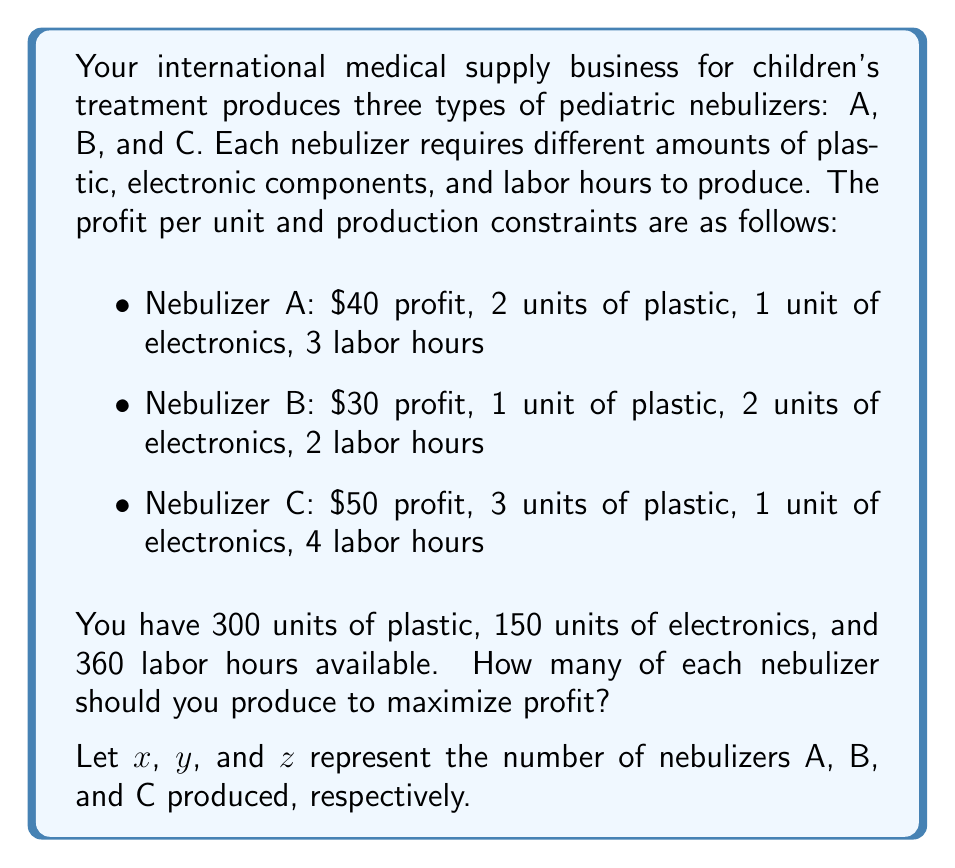Help me with this question. To solve this problem, we'll use a system of linear equations and the simplex method for linear programming. Here's the step-by-step solution:

1. Set up the objective function to maximize profit:
   $$P = 40x + 30y + 50z$$

2. Define the constraints:
   Plastic: $2x + y + 3z \leq 300$
   Electronics: $x + 2y + z \leq 150$
   Labor: $3x + 2y + 4z \leq 360$

3. Add non-negativity constraints:
   $x \geq 0$, $y \geq 0$, $z \geq 0$

4. Convert to standard form by adding slack variables:
   $$2x + y + 3z + s_1 = 300$$
   $$x + 2y + z + s_2 = 150$$
   $$3x + 2y + 4z + s_3 = 360$$

5. Set up the initial simplex tableau:

   $$\begin{array}{c|cccccccc}
    & x & y & z & s_1 & s_2 & s_3 & RHS \\
   \hline
   P & -40 & -30 & -50 & 0 & 0 & 0 & 0 \\
   s_1 & 2 & 1 & 3 & 1 & 0 & 0 & 300 \\
   s_2 & 1 & 2 & 1 & 0 & 1 & 0 & 150 \\
   s_3 & 3 & 2 & 4 & 0 & 0 & 1 & 360
   \end{array}$$

6. Perform pivot operations to optimize the solution. After several iterations, we reach the optimal solution:

   $$\begin{array}{c|cccccccc}
    & x & y & z & s_1 & s_2 & s_3 & RHS \\
   \hline
   P & 0 & 0 & 0 & 10 & 0 & 5 & 3900 \\
   x & 1 & 0 & 0 & 0 & 1/2 & -1/2 & 30 \\
   y & 0 & 1 & 0 & 0 & -1/4 & 1/4 & 45 \\
   z & 0 & 0 & 1 & 1/3 & -1/6 & 1/6 & 60
   \end{array}$$

7. Interpret the results:
   - Produce 30 units of Nebulizer A
   - Produce 45 units of Nebulizer B
   - Produce 60 units of Nebulizer C
   - Maximum profit: $3900
Answer: Produce 30 Nebulizer A, 45 Nebulizer B, and 60 Nebulizer C for maximum profit of $3900. 